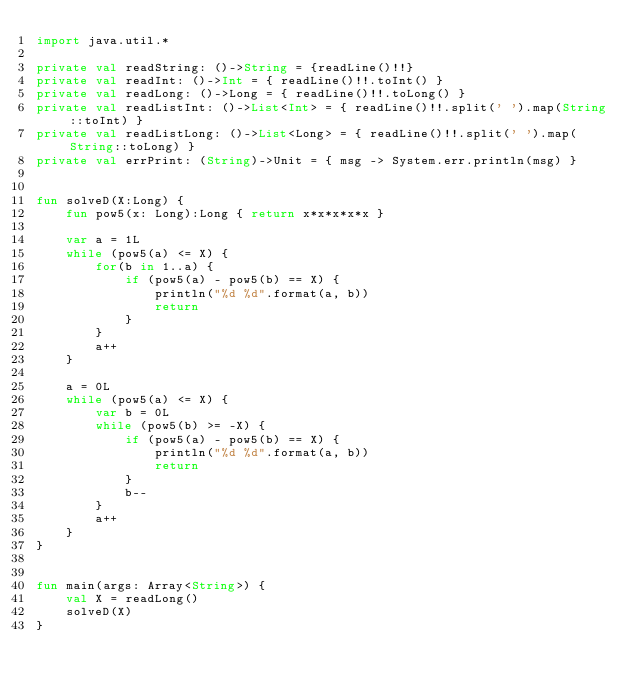<code> <loc_0><loc_0><loc_500><loc_500><_Kotlin_>import java.util.*

private val readString: ()->String = {readLine()!!}
private val readInt: ()->Int = { readLine()!!.toInt() }
private val readLong: ()->Long = { readLine()!!.toLong() }
private val readListInt: ()->List<Int> = { readLine()!!.split(' ').map(String::toInt) }
private val readListLong: ()->List<Long> = { readLine()!!.split(' ').map(String::toLong) }
private val errPrint: (String)->Unit = { msg -> System.err.println(msg) }


fun solveD(X:Long) {
    fun pow5(x: Long):Long { return x*x*x*x*x }

    var a = 1L
    while (pow5(a) <= X) {
        for(b in 1..a) {
            if (pow5(a) - pow5(b) == X) {
                println("%d %d".format(a, b))
                return
            }
        }
        a++
    }

    a = 0L
    while (pow5(a) <= X) {
        var b = 0L
        while (pow5(b) >= -X) {
            if (pow5(a) - pow5(b) == X) {
                println("%d %d".format(a, b))
                return
            }
            b--
        }
        a++
    }
}


fun main(args: Array<String>) {
    val X = readLong()
    solveD(X)
}
</code> 